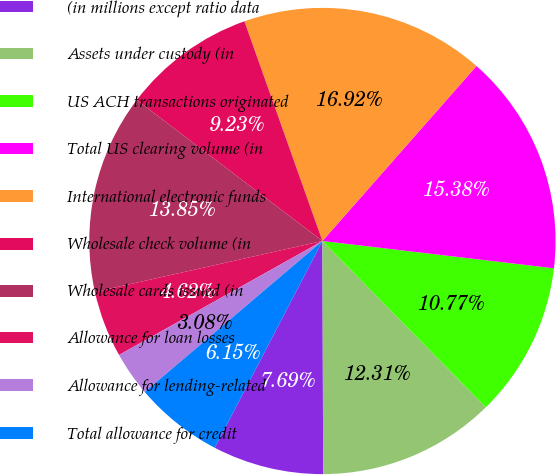<chart> <loc_0><loc_0><loc_500><loc_500><pie_chart><fcel>(in millions except ratio data<fcel>Assets under custody (in<fcel>US ACH transactions originated<fcel>Total US clearing volume (in<fcel>International electronic funds<fcel>Wholesale check volume (in<fcel>Wholesale cards issued (in<fcel>Allowance for loan losses<fcel>Allowance for lending-related<fcel>Total allowance for credit<nl><fcel>7.69%<fcel>12.31%<fcel>10.77%<fcel>15.38%<fcel>16.92%<fcel>9.23%<fcel>13.85%<fcel>4.62%<fcel>3.08%<fcel>6.15%<nl></chart> 